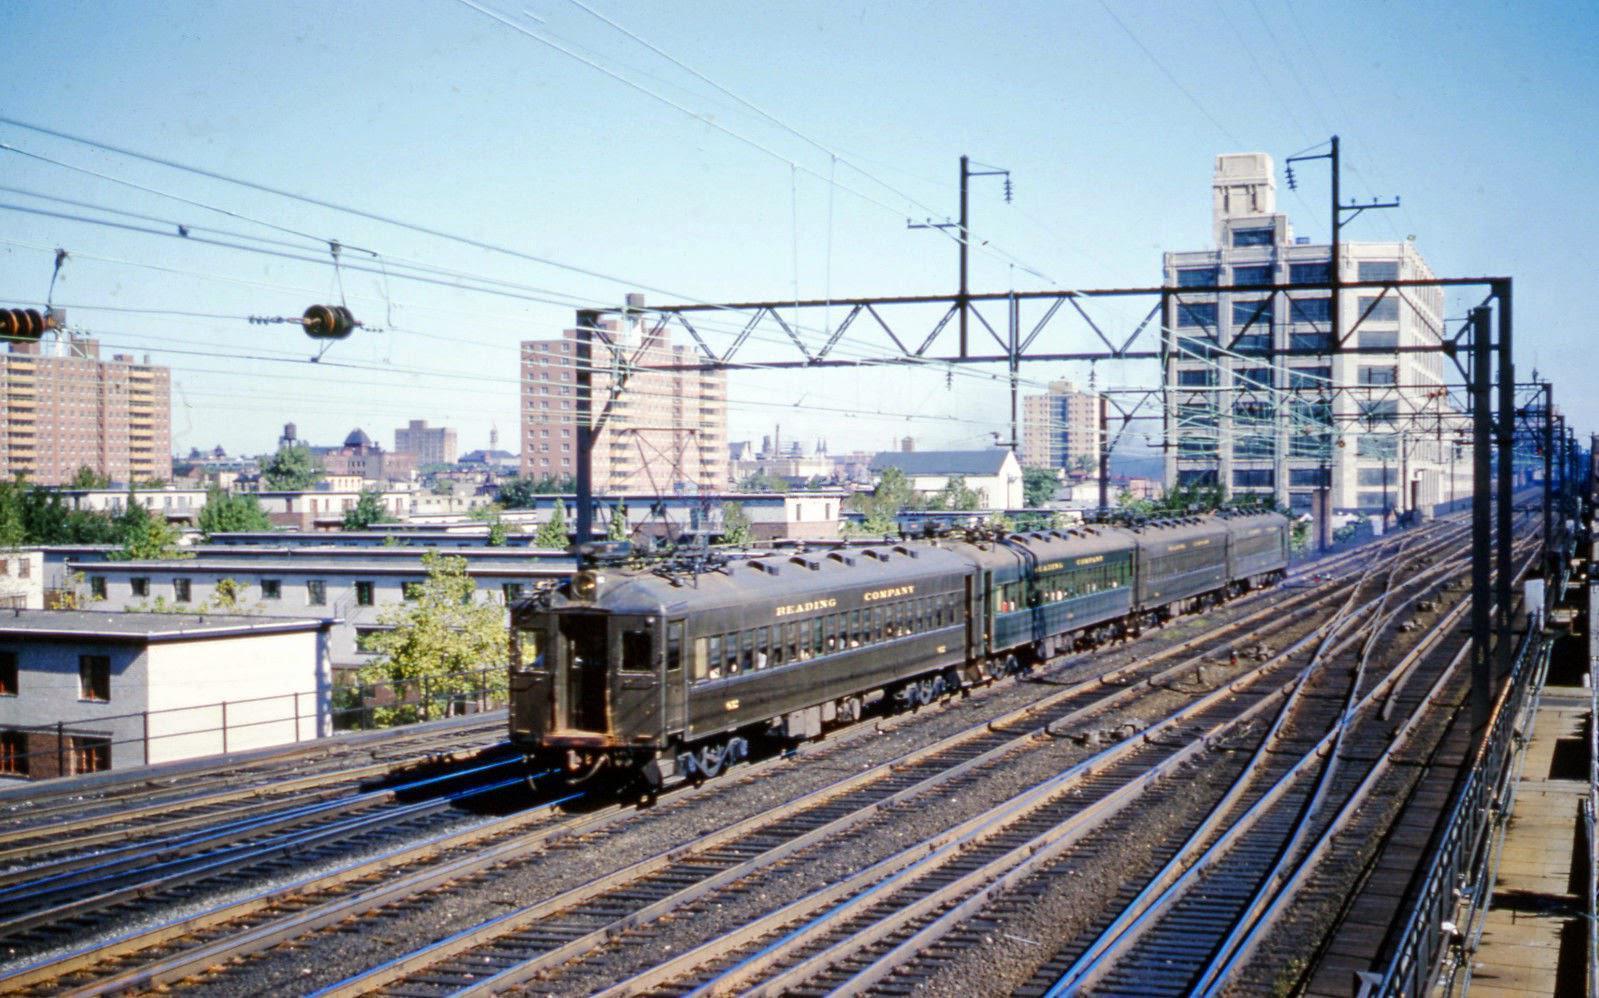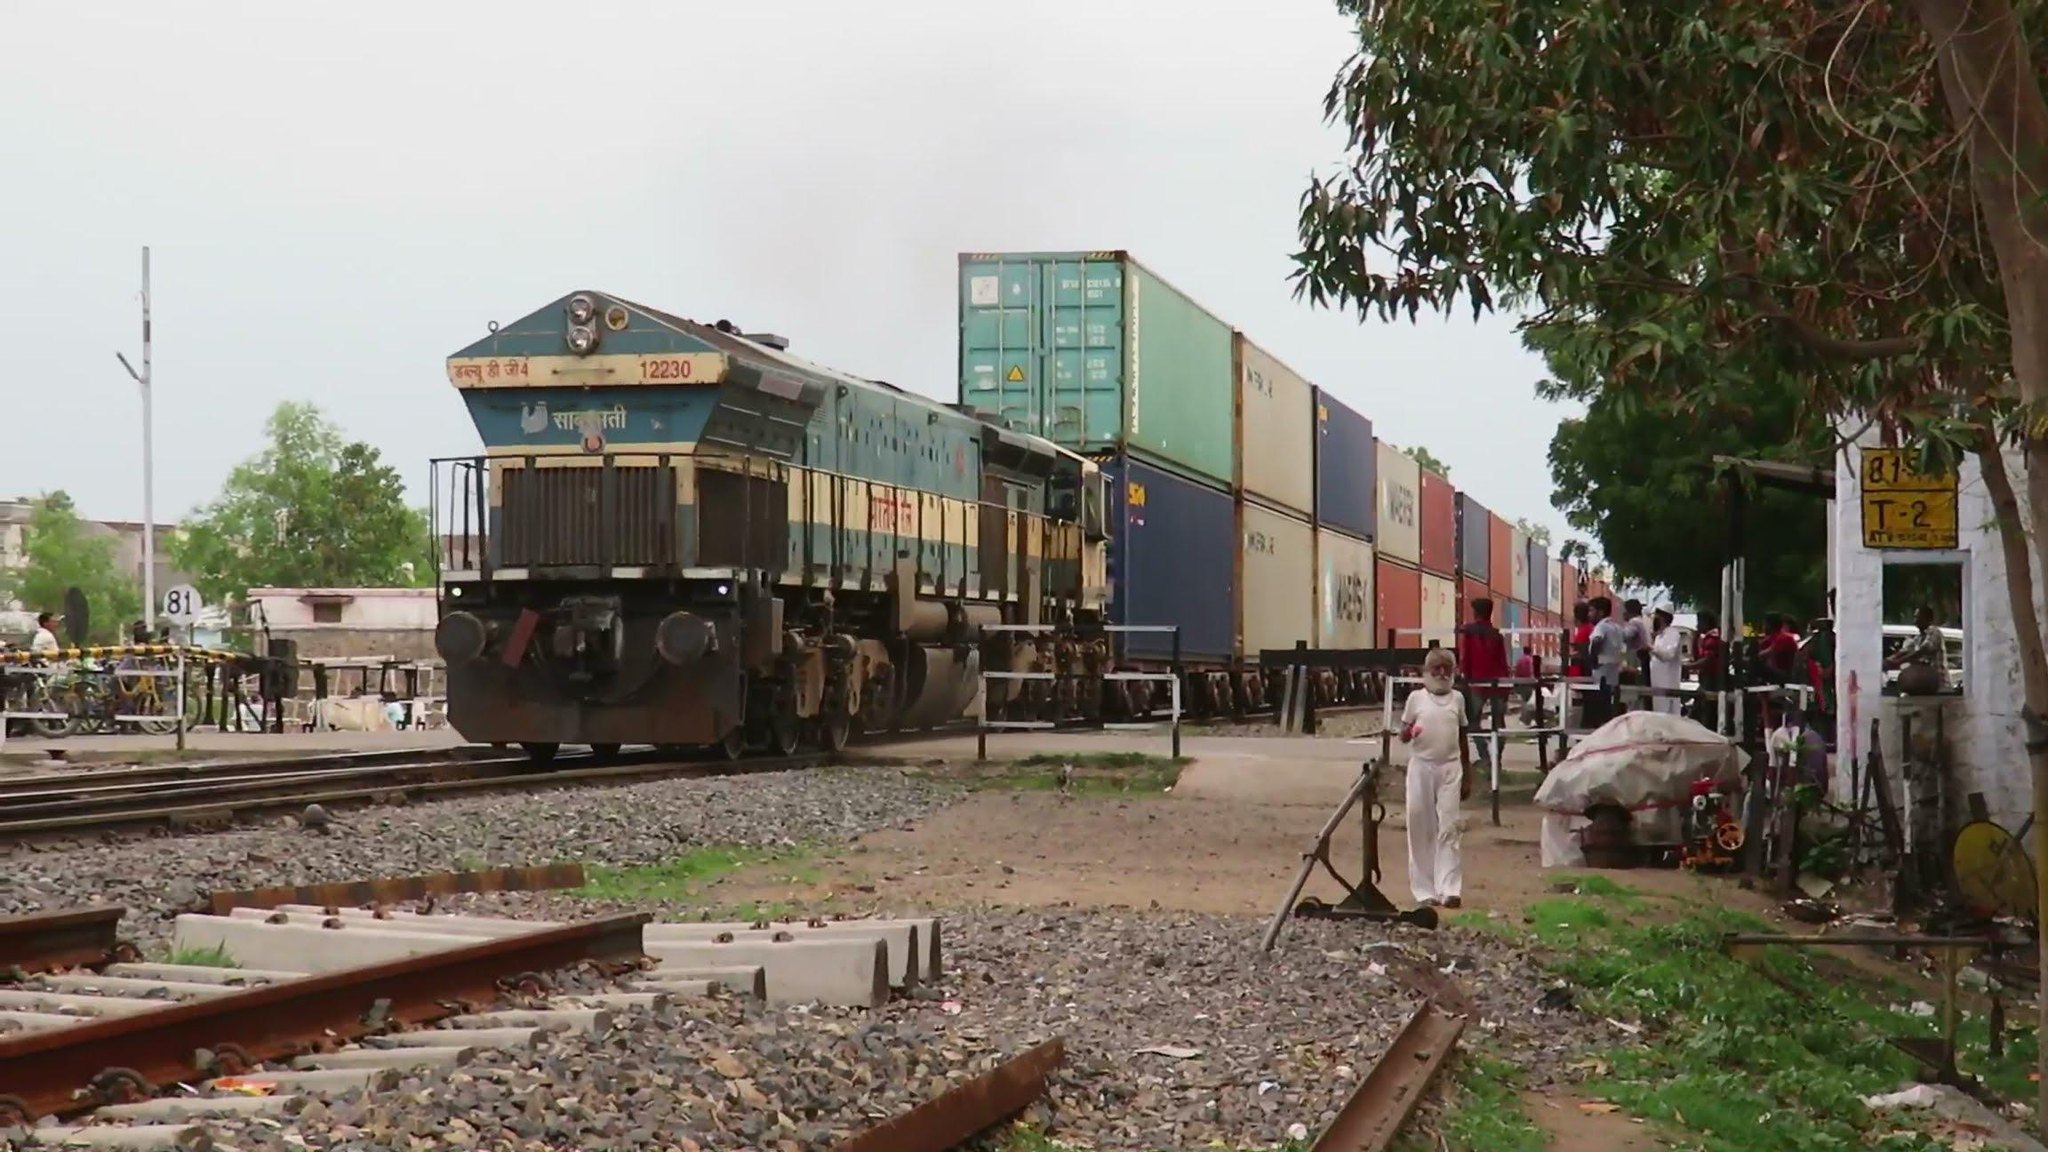The first image is the image on the left, the second image is the image on the right. Examine the images to the left and right. Is the description "An image shows a train going under a structure that spans the tracks with a zig-zag structural element." accurate? Answer yes or no. Yes. The first image is the image on the left, the second image is the image on the right. Evaluate the accuracy of this statement regarding the images: "A predominantly yellow train is traveling slightly towards the right.". Is it true? Answer yes or no. No. 